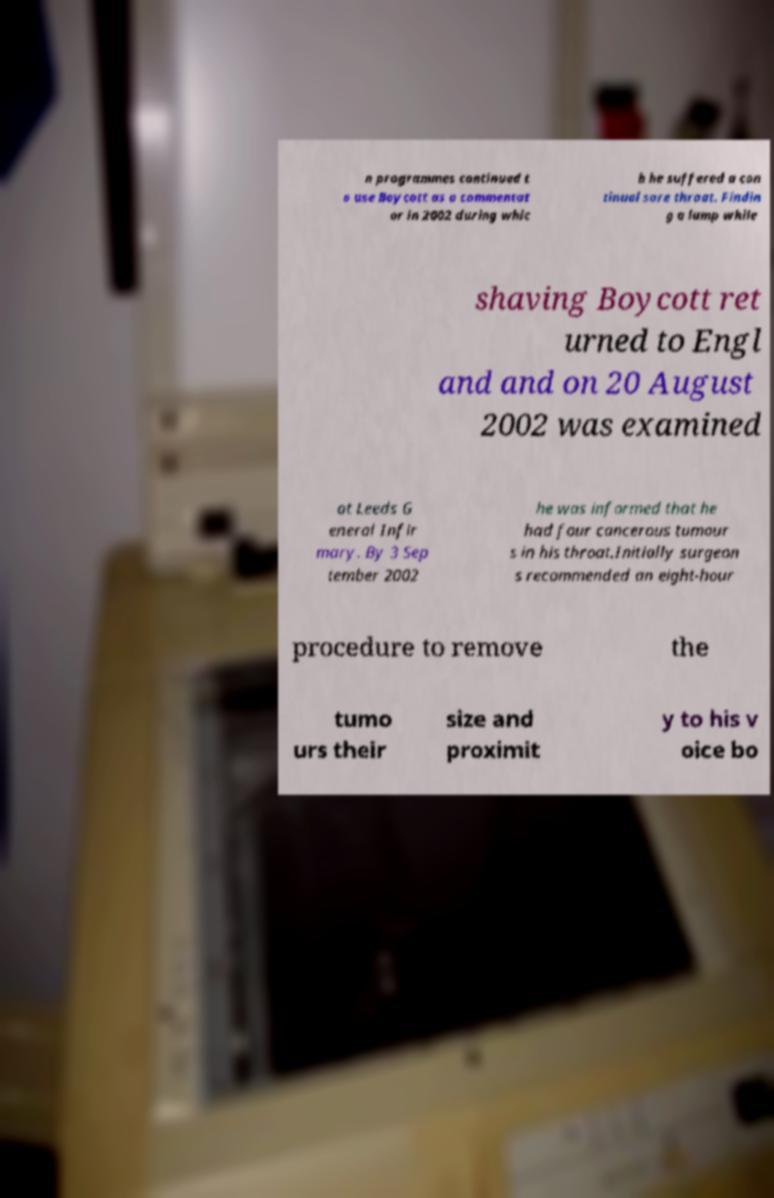Could you extract and type out the text from this image? n programmes continued t o use Boycott as a commentat or in 2002 during whic h he suffered a con tinual sore throat. Findin g a lump while shaving Boycott ret urned to Engl and and on 20 August 2002 was examined at Leeds G eneral Infir mary. By 3 Sep tember 2002 he was informed that he had four cancerous tumour s in his throat.Initially surgeon s recommended an eight-hour procedure to remove the tumo urs their size and proximit y to his v oice bo 